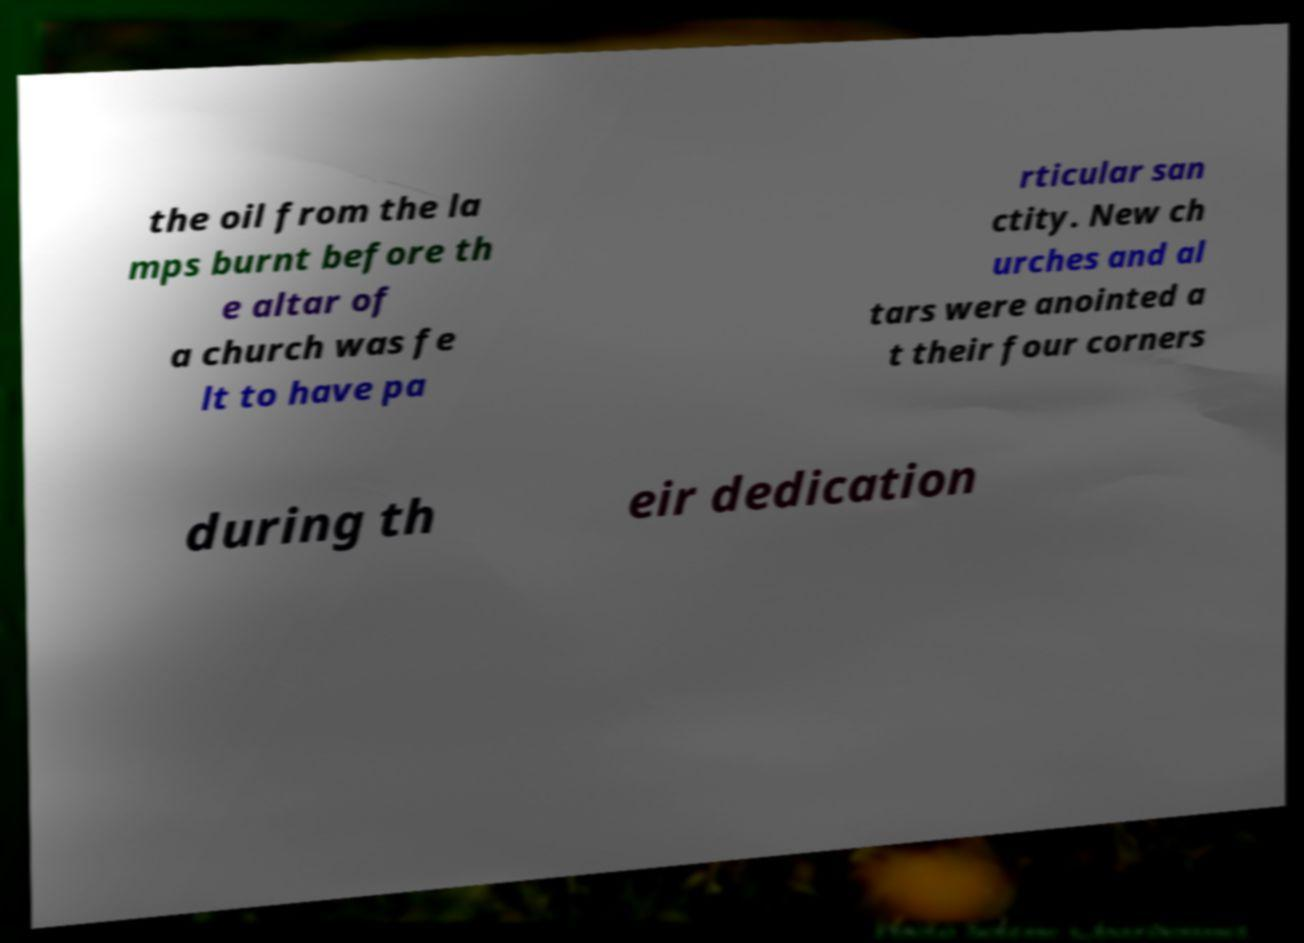I need the written content from this picture converted into text. Can you do that? the oil from the la mps burnt before th e altar of a church was fe lt to have pa rticular san ctity. New ch urches and al tars were anointed a t their four corners during th eir dedication 